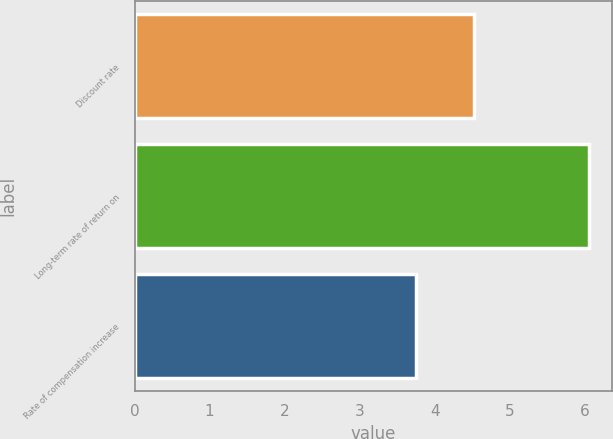Convert chart to OTSL. <chart><loc_0><loc_0><loc_500><loc_500><bar_chart><fcel>Discount rate<fcel>Long-term rate of return on<fcel>Rate of compensation increase<nl><fcel>4.53<fcel>6.06<fcel>3.75<nl></chart> 